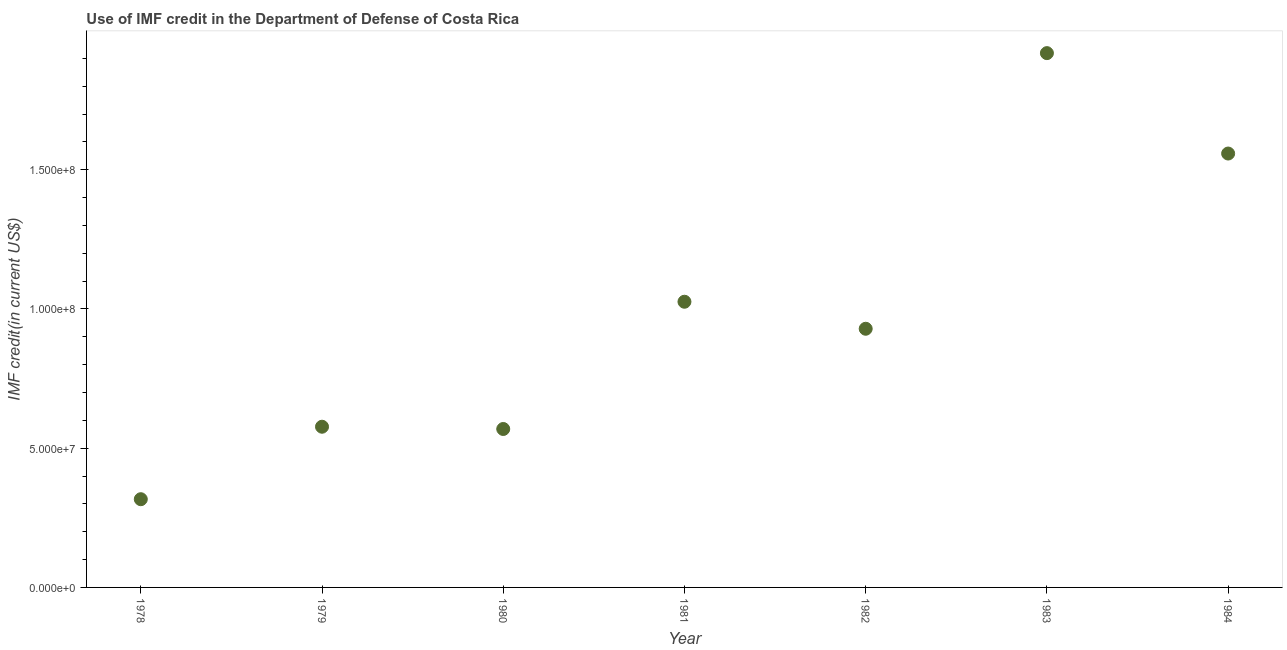What is the use of imf credit in dod in 1983?
Ensure brevity in your answer.  1.92e+08. Across all years, what is the maximum use of imf credit in dod?
Keep it short and to the point. 1.92e+08. Across all years, what is the minimum use of imf credit in dod?
Offer a terse response. 3.17e+07. In which year was the use of imf credit in dod maximum?
Make the answer very short. 1983. In which year was the use of imf credit in dod minimum?
Your response must be concise. 1978. What is the sum of the use of imf credit in dod?
Your answer should be very brief. 6.90e+08. What is the difference between the use of imf credit in dod in 1979 and 1982?
Offer a terse response. -3.52e+07. What is the average use of imf credit in dod per year?
Provide a short and direct response. 9.85e+07. What is the median use of imf credit in dod?
Give a very brief answer. 9.29e+07. What is the ratio of the use of imf credit in dod in 1979 to that in 1980?
Give a very brief answer. 1.01. Is the use of imf credit in dod in 1978 less than that in 1982?
Your answer should be very brief. Yes. What is the difference between the highest and the second highest use of imf credit in dod?
Offer a terse response. 3.61e+07. Is the sum of the use of imf credit in dod in 1978 and 1979 greater than the maximum use of imf credit in dod across all years?
Provide a succinct answer. No. What is the difference between the highest and the lowest use of imf credit in dod?
Ensure brevity in your answer.  1.60e+08. In how many years, is the use of imf credit in dod greater than the average use of imf credit in dod taken over all years?
Your answer should be compact. 3. Does the use of imf credit in dod monotonically increase over the years?
Your answer should be very brief. No. How many dotlines are there?
Give a very brief answer. 1. What is the difference between two consecutive major ticks on the Y-axis?
Give a very brief answer. 5.00e+07. Are the values on the major ticks of Y-axis written in scientific E-notation?
Make the answer very short. Yes. Does the graph contain any zero values?
Make the answer very short. No. Does the graph contain grids?
Keep it short and to the point. No. What is the title of the graph?
Provide a succinct answer. Use of IMF credit in the Department of Defense of Costa Rica. What is the label or title of the Y-axis?
Make the answer very short. IMF credit(in current US$). What is the IMF credit(in current US$) in 1978?
Provide a succinct answer. 3.17e+07. What is the IMF credit(in current US$) in 1979?
Keep it short and to the point. 5.77e+07. What is the IMF credit(in current US$) in 1980?
Your answer should be very brief. 5.69e+07. What is the IMF credit(in current US$) in 1981?
Your answer should be compact. 1.03e+08. What is the IMF credit(in current US$) in 1982?
Offer a very short reply. 9.29e+07. What is the IMF credit(in current US$) in 1983?
Your response must be concise. 1.92e+08. What is the IMF credit(in current US$) in 1984?
Your answer should be compact. 1.56e+08. What is the difference between the IMF credit(in current US$) in 1978 and 1979?
Give a very brief answer. -2.60e+07. What is the difference between the IMF credit(in current US$) in 1978 and 1980?
Give a very brief answer. -2.52e+07. What is the difference between the IMF credit(in current US$) in 1978 and 1981?
Your response must be concise. -7.09e+07. What is the difference between the IMF credit(in current US$) in 1978 and 1982?
Your answer should be compact. -6.12e+07. What is the difference between the IMF credit(in current US$) in 1978 and 1983?
Your answer should be very brief. -1.60e+08. What is the difference between the IMF credit(in current US$) in 1978 and 1984?
Keep it short and to the point. -1.24e+08. What is the difference between the IMF credit(in current US$) in 1979 and 1980?
Offer a terse response. 8.12e+05. What is the difference between the IMF credit(in current US$) in 1979 and 1981?
Keep it short and to the point. -4.49e+07. What is the difference between the IMF credit(in current US$) in 1979 and 1982?
Keep it short and to the point. -3.52e+07. What is the difference between the IMF credit(in current US$) in 1979 and 1983?
Provide a short and direct response. -1.34e+08. What is the difference between the IMF credit(in current US$) in 1979 and 1984?
Provide a short and direct response. -9.81e+07. What is the difference between the IMF credit(in current US$) in 1980 and 1981?
Your answer should be very brief. -4.57e+07. What is the difference between the IMF credit(in current US$) in 1980 and 1982?
Provide a succinct answer. -3.60e+07. What is the difference between the IMF credit(in current US$) in 1980 and 1983?
Make the answer very short. -1.35e+08. What is the difference between the IMF credit(in current US$) in 1980 and 1984?
Your answer should be very brief. -9.89e+07. What is the difference between the IMF credit(in current US$) in 1981 and 1982?
Your response must be concise. 9.70e+06. What is the difference between the IMF credit(in current US$) in 1981 and 1983?
Provide a short and direct response. -8.93e+07. What is the difference between the IMF credit(in current US$) in 1981 and 1984?
Give a very brief answer. -5.32e+07. What is the difference between the IMF credit(in current US$) in 1982 and 1983?
Keep it short and to the point. -9.90e+07. What is the difference between the IMF credit(in current US$) in 1982 and 1984?
Offer a very short reply. -6.29e+07. What is the difference between the IMF credit(in current US$) in 1983 and 1984?
Offer a terse response. 3.61e+07. What is the ratio of the IMF credit(in current US$) in 1978 to that in 1979?
Provide a succinct answer. 0.55. What is the ratio of the IMF credit(in current US$) in 1978 to that in 1980?
Your answer should be compact. 0.56. What is the ratio of the IMF credit(in current US$) in 1978 to that in 1981?
Your answer should be very brief. 0.31. What is the ratio of the IMF credit(in current US$) in 1978 to that in 1982?
Keep it short and to the point. 0.34. What is the ratio of the IMF credit(in current US$) in 1978 to that in 1983?
Give a very brief answer. 0.17. What is the ratio of the IMF credit(in current US$) in 1978 to that in 1984?
Your response must be concise. 0.2. What is the ratio of the IMF credit(in current US$) in 1979 to that in 1980?
Your answer should be very brief. 1.01. What is the ratio of the IMF credit(in current US$) in 1979 to that in 1981?
Make the answer very short. 0.56. What is the ratio of the IMF credit(in current US$) in 1979 to that in 1982?
Keep it short and to the point. 0.62. What is the ratio of the IMF credit(in current US$) in 1979 to that in 1983?
Make the answer very short. 0.3. What is the ratio of the IMF credit(in current US$) in 1979 to that in 1984?
Keep it short and to the point. 0.37. What is the ratio of the IMF credit(in current US$) in 1980 to that in 1981?
Your answer should be compact. 0.56. What is the ratio of the IMF credit(in current US$) in 1980 to that in 1982?
Your response must be concise. 0.61. What is the ratio of the IMF credit(in current US$) in 1980 to that in 1983?
Give a very brief answer. 0.3. What is the ratio of the IMF credit(in current US$) in 1980 to that in 1984?
Your answer should be compact. 0.36. What is the ratio of the IMF credit(in current US$) in 1981 to that in 1982?
Give a very brief answer. 1.1. What is the ratio of the IMF credit(in current US$) in 1981 to that in 1983?
Offer a very short reply. 0.54. What is the ratio of the IMF credit(in current US$) in 1981 to that in 1984?
Keep it short and to the point. 0.66. What is the ratio of the IMF credit(in current US$) in 1982 to that in 1983?
Your answer should be compact. 0.48. What is the ratio of the IMF credit(in current US$) in 1982 to that in 1984?
Make the answer very short. 0.6. What is the ratio of the IMF credit(in current US$) in 1983 to that in 1984?
Give a very brief answer. 1.23. 